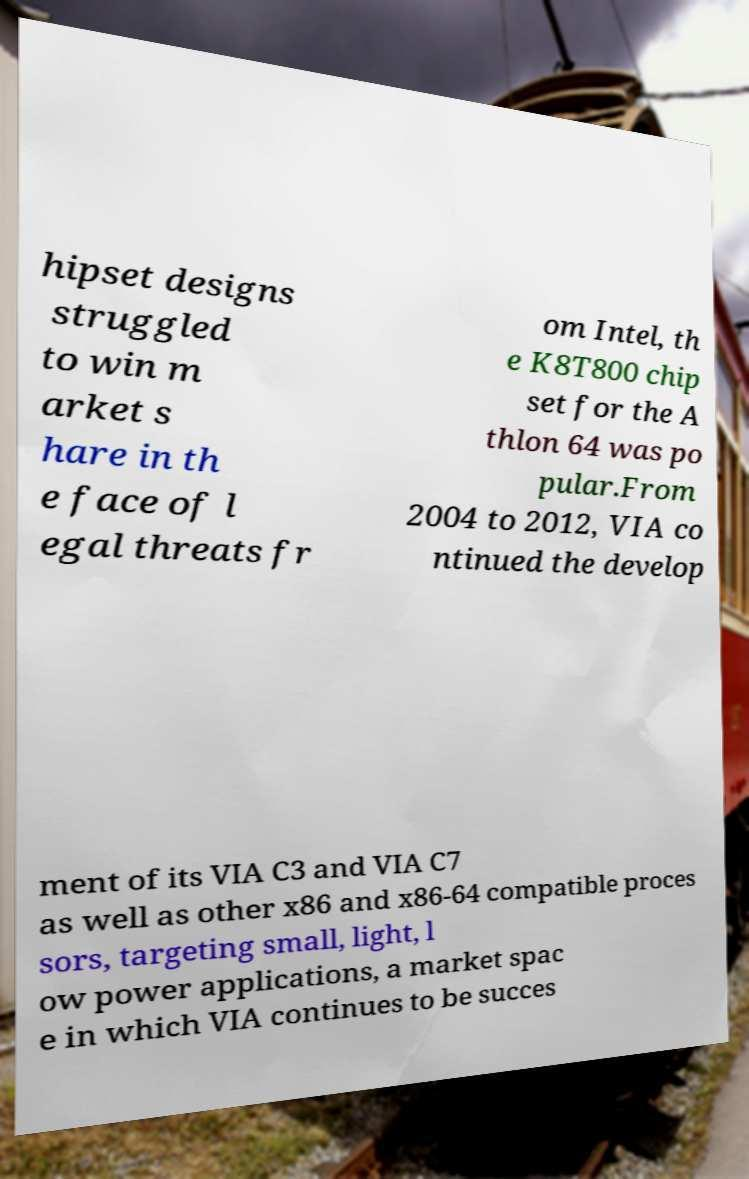There's text embedded in this image that I need extracted. Can you transcribe it verbatim? hipset designs struggled to win m arket s hare in th e face of l egal threats fr om Intel, th e K8T800 chip set for the A thlon 64 was po pular.From 2004 to 2012, VIA co ntinued the develop ment of its VIA C3 and VIA C7 as well as other x86 and x86-64 compatible proces sors, targeting small, light, l ow power applications, a market spac e in which VIA continues to be succes 